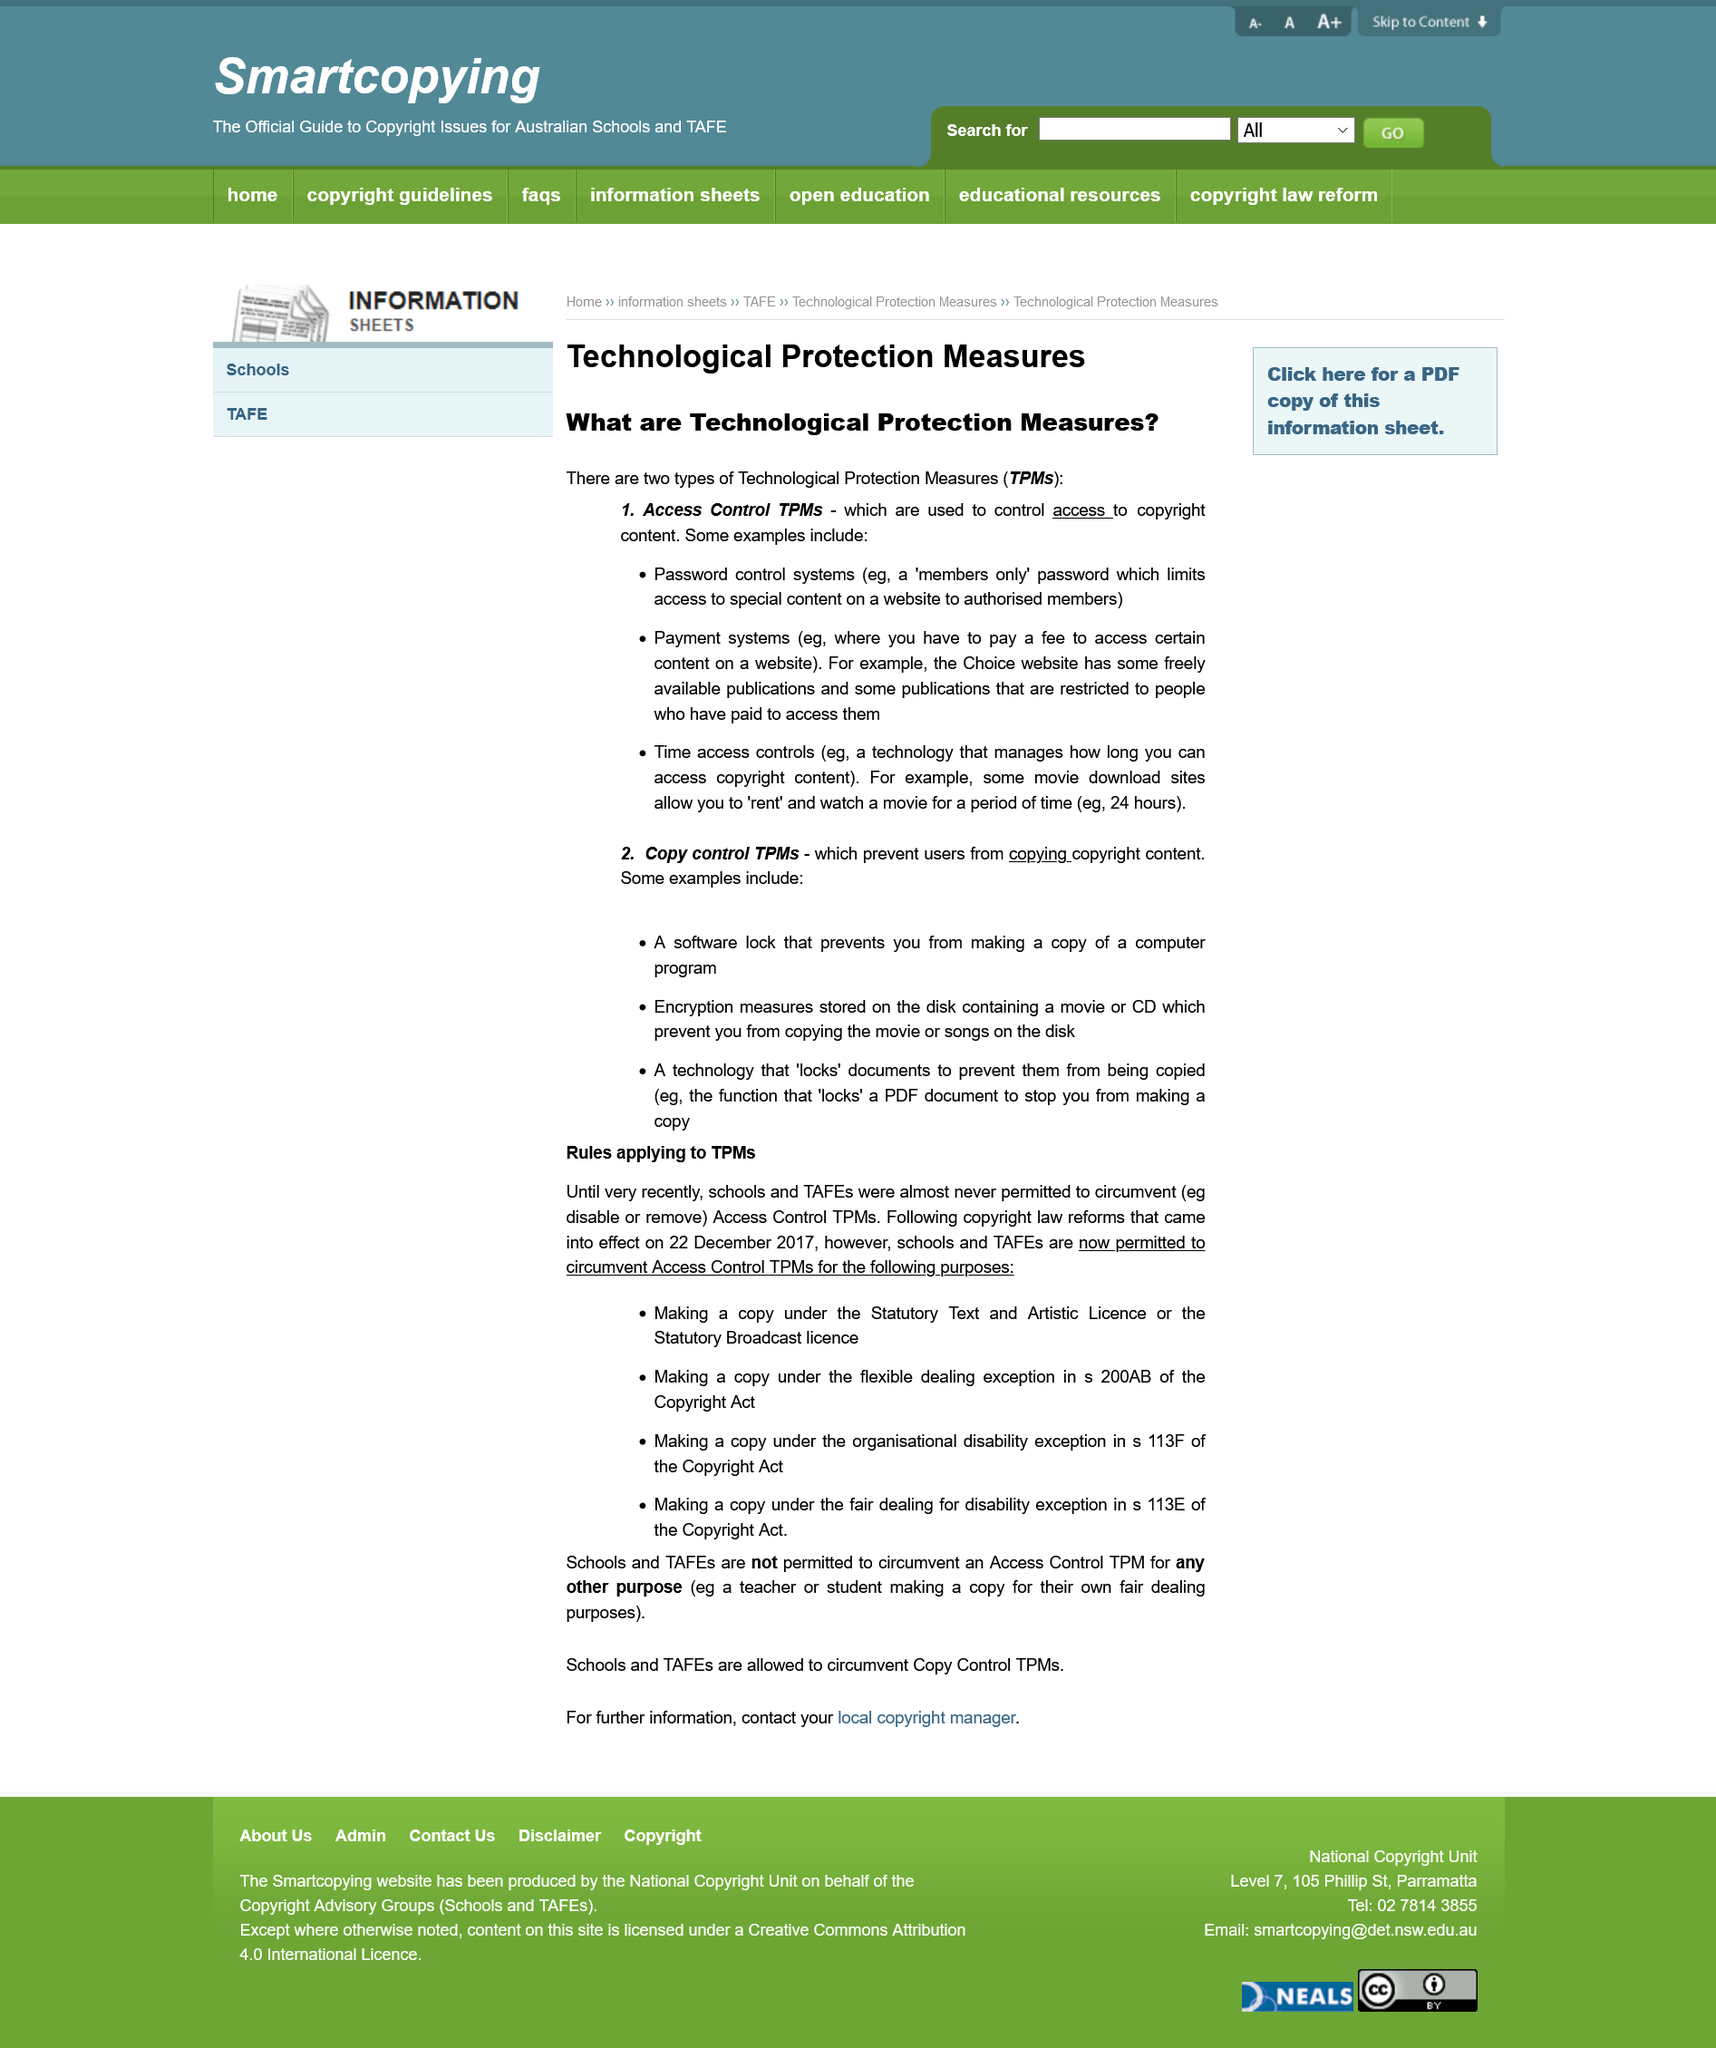Identify some key points in this picture. Access control TPMs are used to restrict access to copyrighted content. It was not possible for TAFEs to make unauthorized copies of digital content using Access Control TPMs before 2017, as such actions would have violated the Statutory Text and Artistic Licence. Section 200AB of the Copyright Act pertains to flexible dealing exceptions. In 2017, copyright reforms enabled schools and TAFEs to bypass Access Control TPMs. We control passwords by using members-only passwords that limit access. 